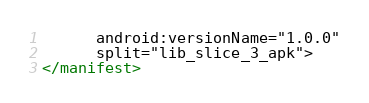Convert code to text. <code><loc_0><loc_0><loc_500><loc_500><_XML_>      android:versionName="1.0.0"
      split="lib_slice_3_apk">
</manifest>
</code> 